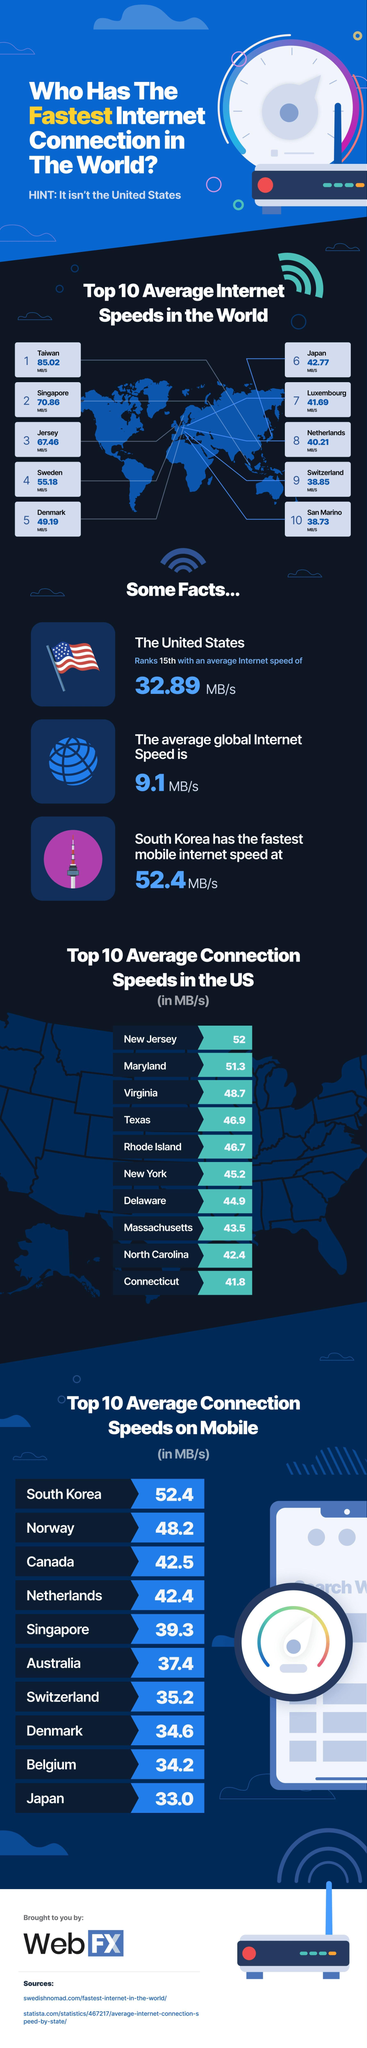Which country has the highest average connection speeds on mobile?
Answer the question with a short phrase. South Korea Which US state has the highest average connection speed? New Jersey Which country has the highest average internet speeds in the world? Taiwan 